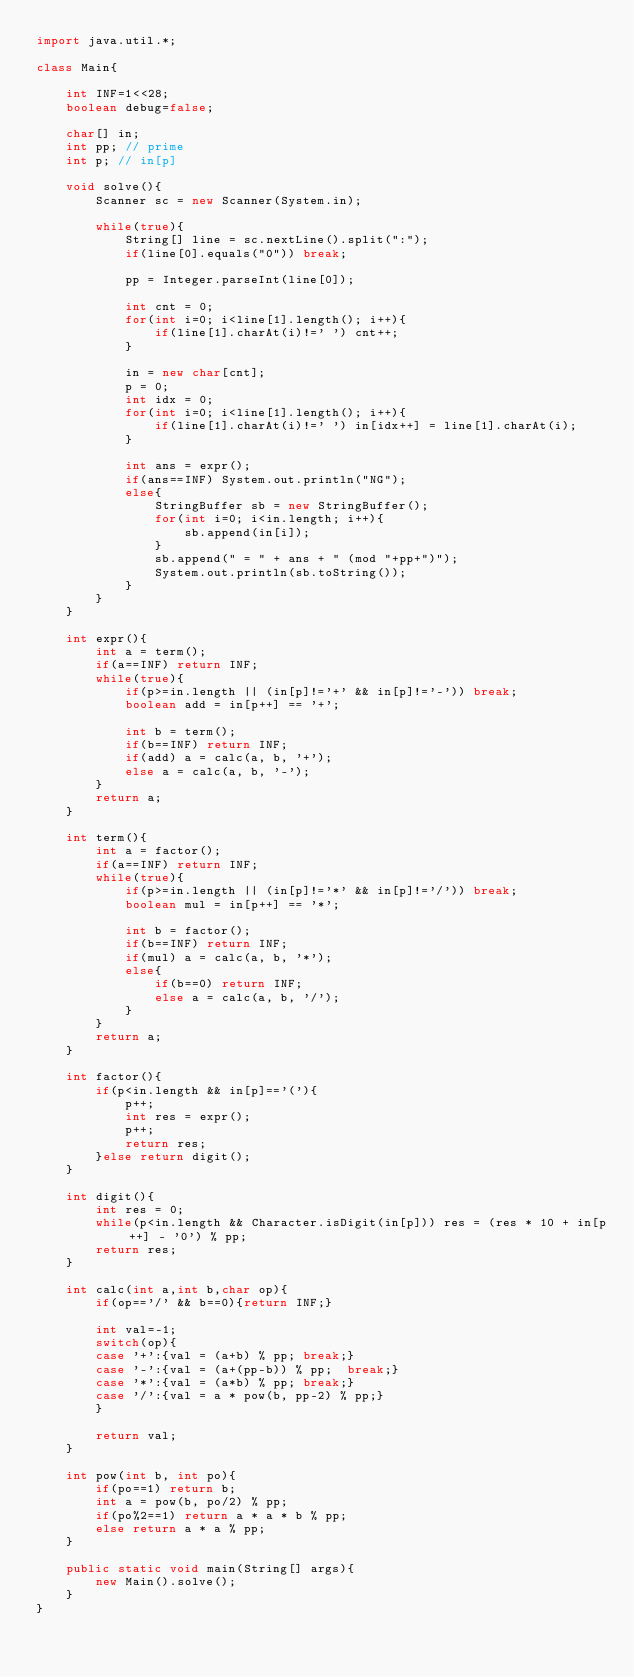Convert code to text. <code><loc_0><loc_0><loc_500><loc_500><_Java_>import java.util.*;

class Main{
    
    int INF=1<<28;
    boolean debug=false;
    
    char[] in;
    int pp; // prime
    int p; // in[p]
    
    void solve(){
        Scanner sc = new Scanner(System.in);
        
        while(true){
            String[] line = sc.nextLine().split(":");
            if(line[0].equals("0")) break;
            
            pp = Integer.parseInt(line[0]);
            
            int cnt = 0;
            for(int i=0; i<line[1].length(); i++){
                if(line[1].charAt(i)!=' ') cnt++;
            }
            
            in = new char[cnt];
            p = 0;
            int idx = 0;
            for(int i=0; i<line[1].length(); i++){
                if(line[1].charAt(i)!=' ') in[idx++] = line[1].charAt(i);
            }
            
            int ans = expr();
            if(ans==INF) System.out.println("NG");
            else{
                StringBuffer sb = new StringBuffer();
                for(int i=0; i<in.length; i++){
                    sb.append(in[i]);
                }
                sb.append(" = " + ans + " (mod "+pp+")");
                System.out.println(sb.toString());
            }
        }
    }
    
    int expr(){
        int a = term();
        if(a==INF) return INF;
        while(true){
            if(p>=in.length || (in[p]!='+' && in[p]!='-')) break;
            boolean add = in[p++] == '+';
            
            int b = term();
            if(b==INF) return INF;
            if(add) a = calc(a, b, '+');
            else a = calc(a, b, '-');
        }
        return a;
    }
    
    int term(){
        int a = factor();
        if(a==INF) return INF;
        while(true){
            if(p>=in.length || (in[p]!='*' && in[p]!='/')) break;
            boolean mul = in[p++] == '*';
            
            int b = factor();
            if(b==INF) return INF;
            if(mul) a = calc(a, b, '*');
            else{
                if(b==0) return INF;
                else a = calc(a, b, '/');
            }
        }
        return a;
    }
    
    int factor(){
        if(p<in.length && in[p]=='('){
            p++;
            int res = expr();
            p++;
            return res;
        }else return digit();
    }
 
    int digit(){
        int res = 0;
        while(p<in.length && Character.isDigit(in[p])) res = (res * 10 + in[p++] - '0') % pp;
        return res;
    }
 
    int calc(int a,int b,char op){
        if(op=='/' && b==0){return INF;}
     
        int val=-1;
        switch(op){
        case '+':{val = (a+b) % pp; break;}
        case '-':{val = (a+(pp-b)) % pp;  break;}
        case '*':{val = (a*b) % pp; break;}
        case '/':{val = a * pow(b, pp-2) % pp;}
        }
        
        return val;
    }
 
    int pow(int b, int po){
        if(po==1) return b;
        int a = pow(b, po/2) % pp;
        if(po%2==1) return a * a * b % pp;
        else return a * a % pp;
    }
 
    public static void main(String[] args){
        new Main().solve();
    }
}</code> 